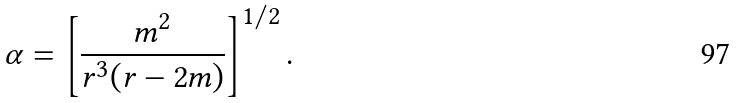Convert formula to latex. <formula><loc_0><loc_0><loc_500><loc_500>\alpha = \left [ \frac { m ^ { 2 } } { r ^ { 3 } ( r - 2 m ) } \right ] ^ { 1 / 2 } .</formula> 